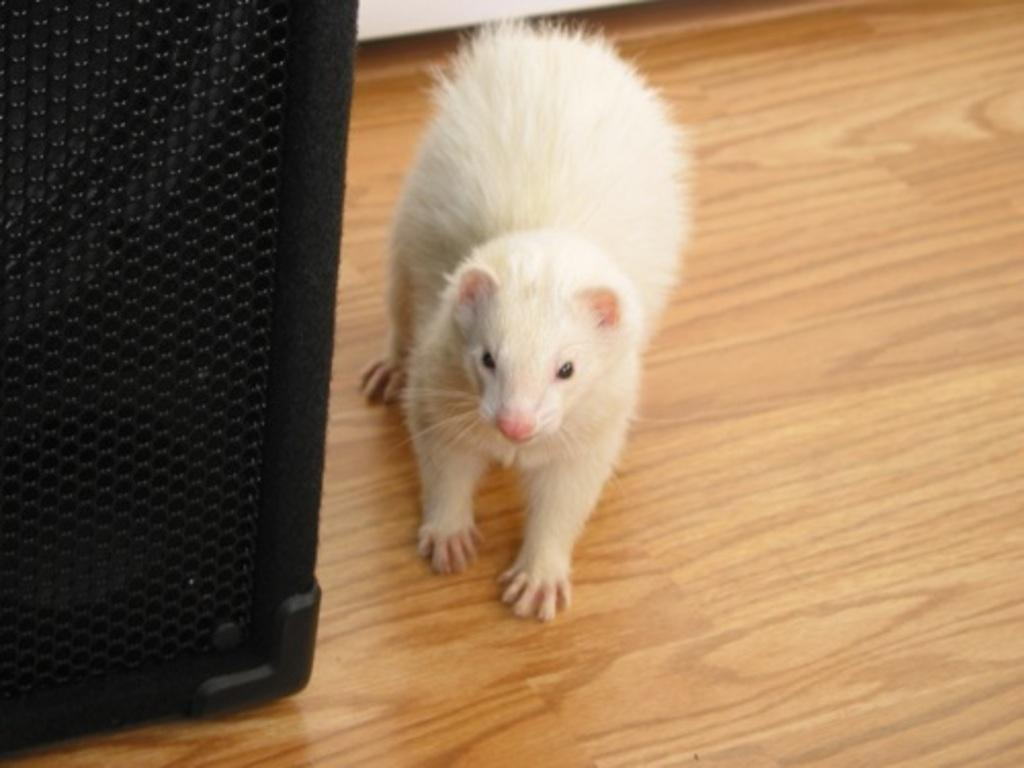What type of animal is in the image? The animal in the image is white in color. What is the object next to the animal? There is a sound box in the image. Where is the sound box located in relation to the animal? The sound box is on the left side of the image. What is the color of the surface that the animal and sound box are on? The animal and sound box are on a brown color surface. Can you see any pets performing magic tricks on the slope in the image? There is no slope, pets, or magic tricks present in the image. 